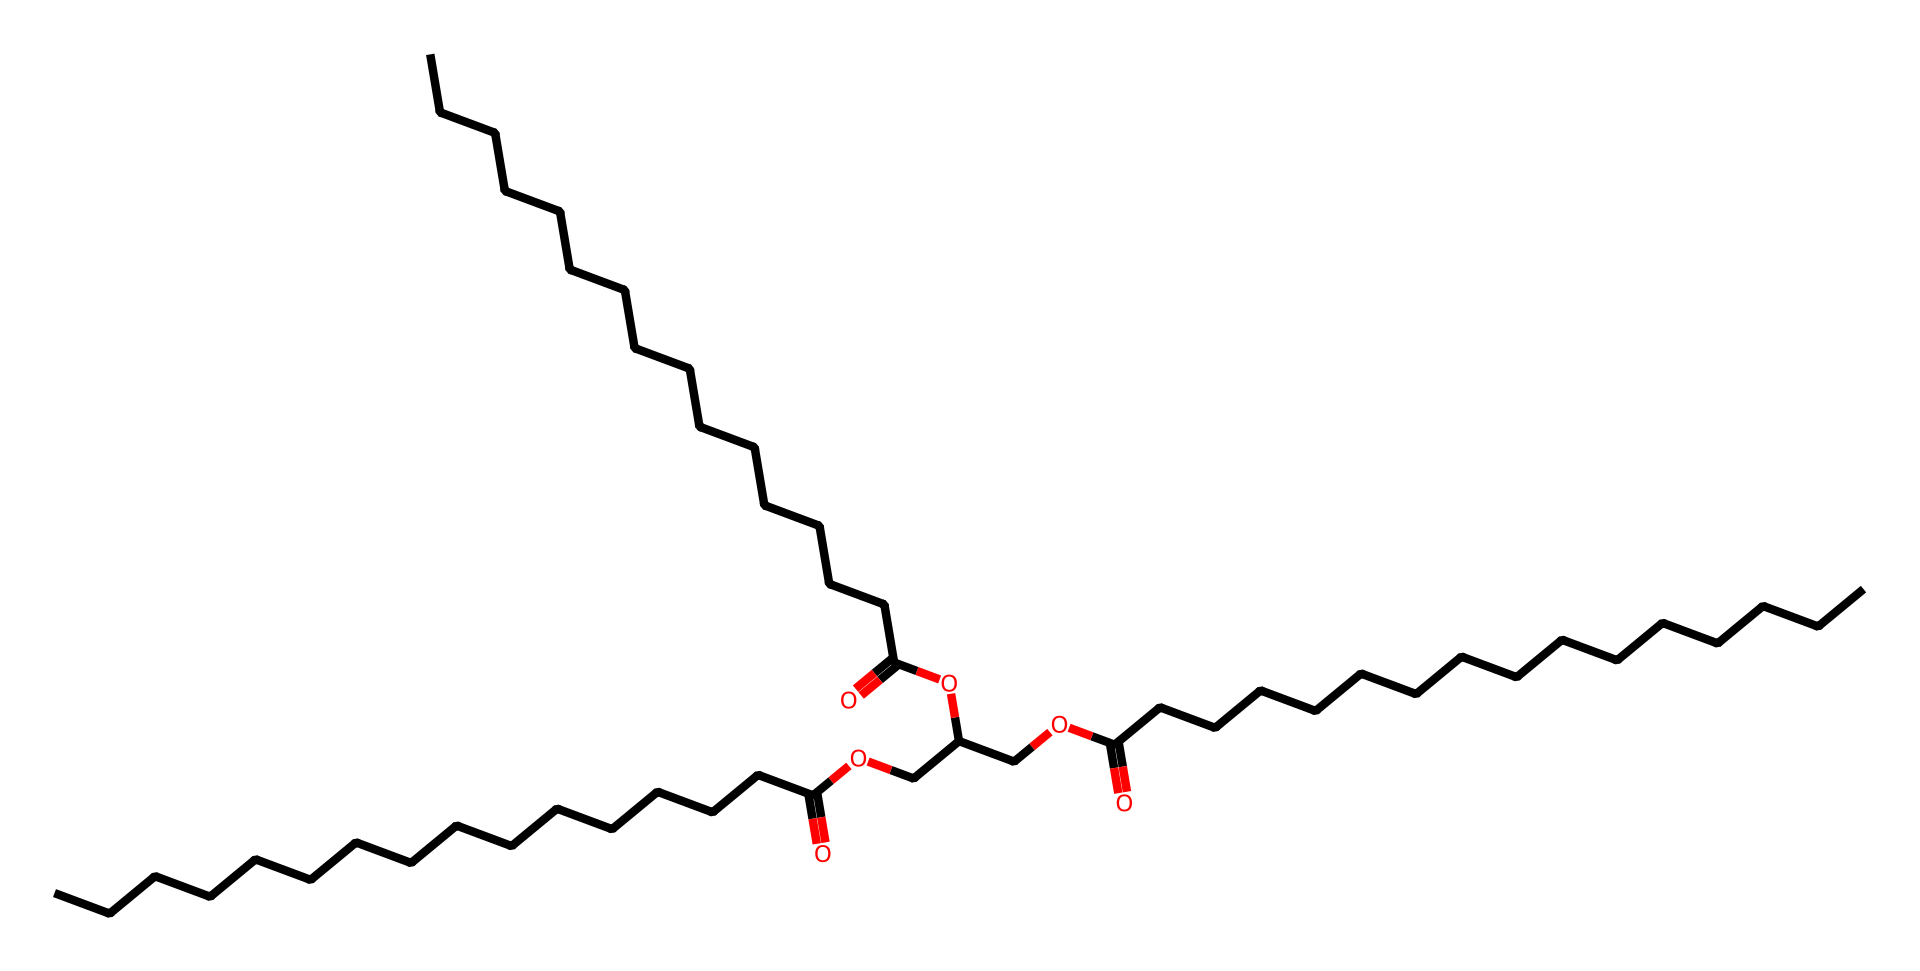What type of lipid does this chemical represent? The chemical structure indicates it is a triglyceride, which is characterized by three fatty acid chains linked to a glycerol backbone.
Answer: triglyceride How many fatty acid chains are present in this structure? The structure shows three distinct fatty acid chains connected to the glycerol, which is a hallmark of triglycerides.
Answer: three What functional groups are present in this molecule? The structure reveals carboxylic acid groups (-COOH) from the fatty acids and ester groups (–COO–) where the fatty acids connect to the glycerol.
Answer: carboxylic and ester How many carbon atoms are present in total? By analyzing the structure, we can count a total of 60 carbon atoms, which is derived from the glycerol and the three long-chain fatty acids.
Answer: sixty What is the primary role of triglycerides in high-performance sports? Triglycerides serve as a significant energy storage form, providing a dense source of energy during prolonged physical activity, which is crucial for high-performance athletes.
Answer: energy storage Why are triglycerides important for energy during exercise? Triglycerides break down into fatty acids and glycerol, providing a stable and concentrated source of energy that can be utilized during extended exercise, making them essential for endurance activities.
Answer: concentrated energy source 